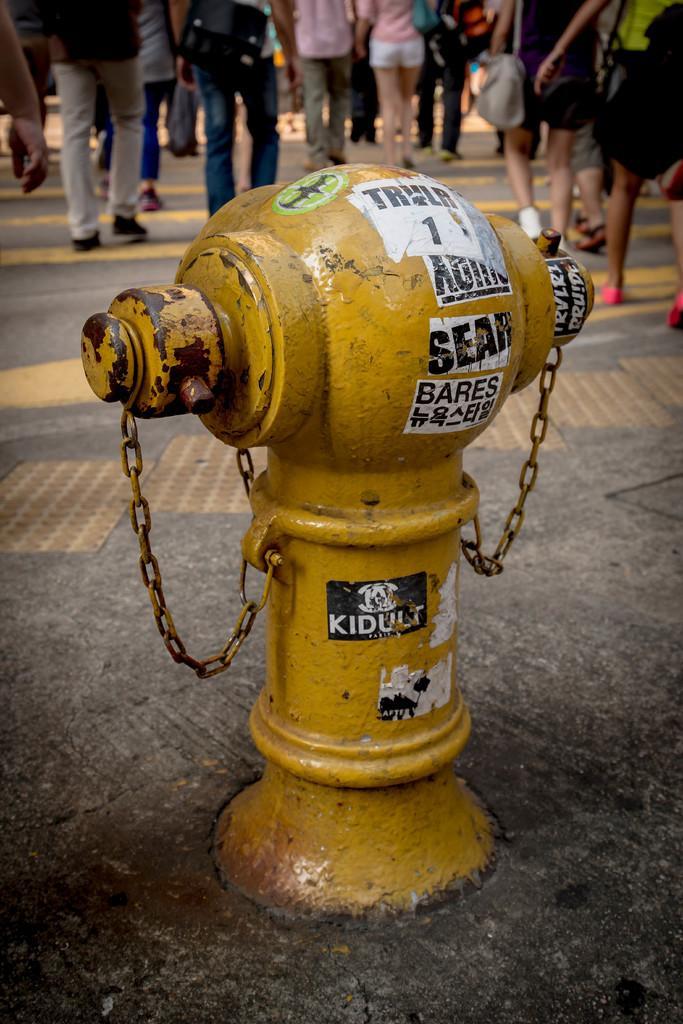Describe this image in one or two sentences. In this picture we can see a yellow fire hydrant with chains on the path. Behind the fire hydrant there are some people walking on the path. 